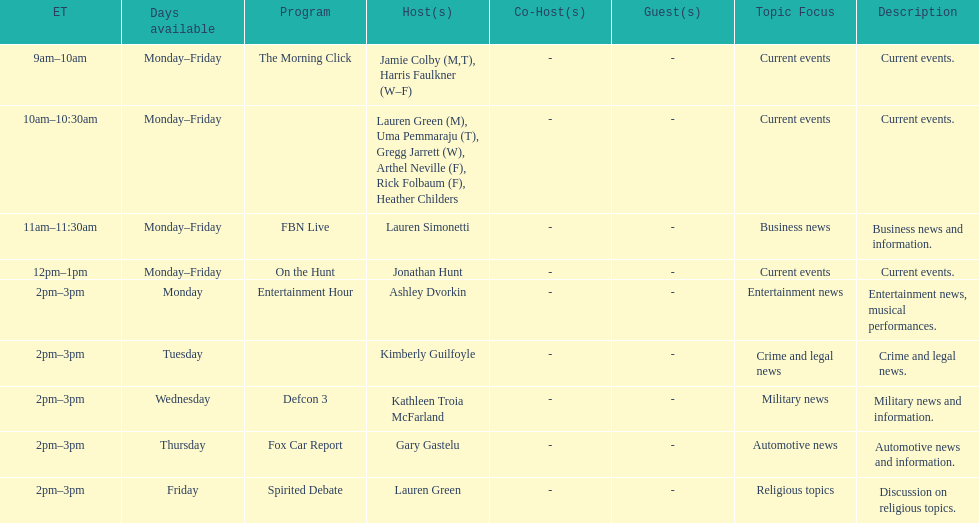Which program is only available on thursdays? Fox Car Report. 